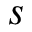<formula> <loc_0><loc_0><loc_500><loc_500>s</formula> 